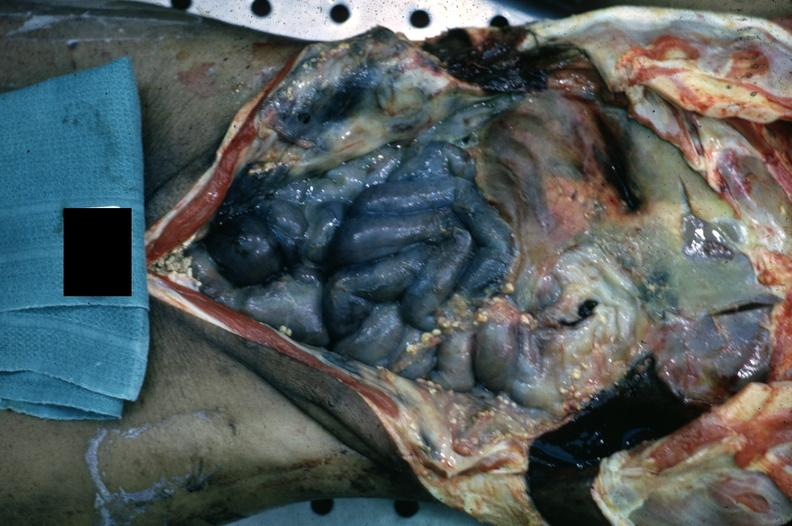does this image show opened body cavity with necrotic bowel and heavy fibrin exudate?
Answer the question using a single word or phrase. Yes 